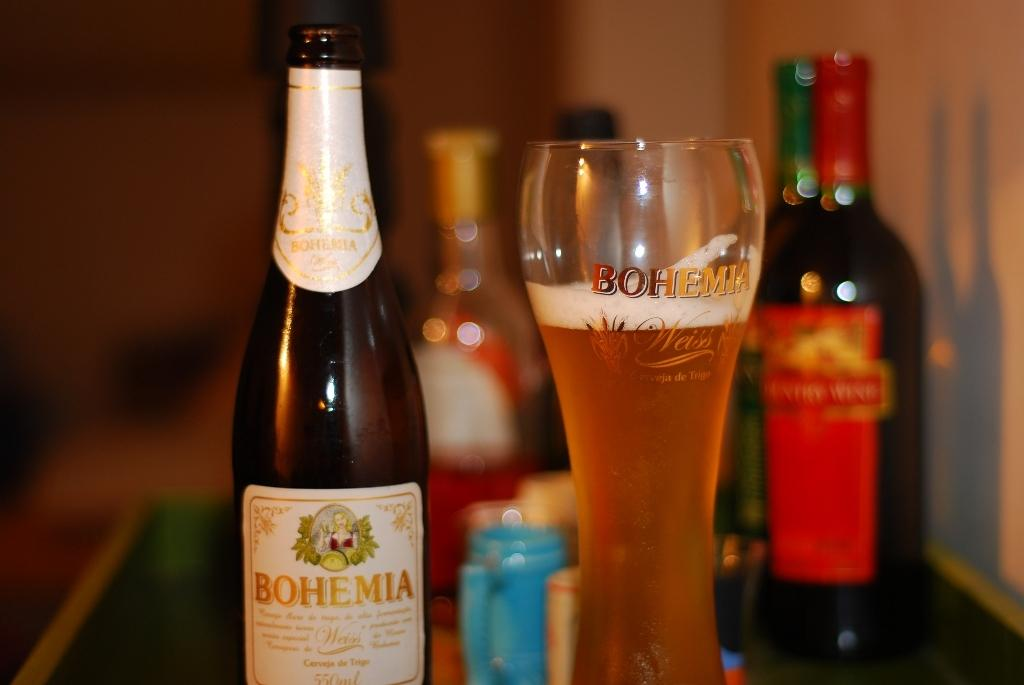Provide a one-sentence caption for the provided image. A bottle of bohemia branded alcohol with a glass that has the same brand on it. 